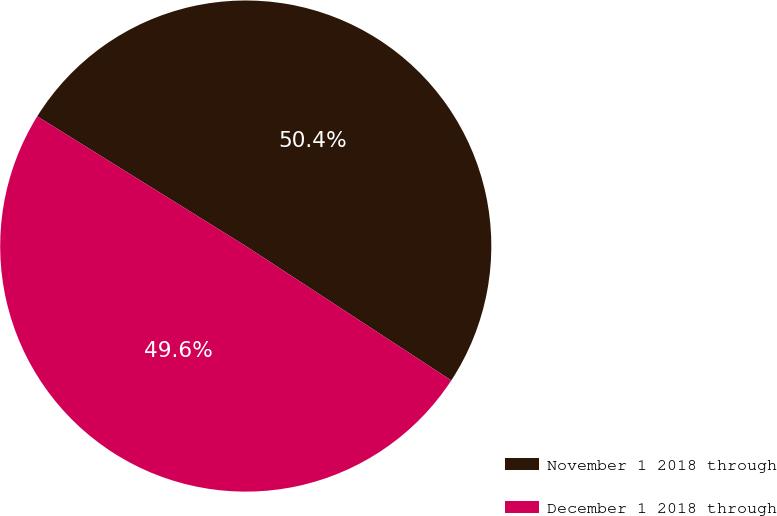Convert chart to OTSL. <chart><loc_0><loc_0><loc_500><loc_500><pie_chart><fcel>November 1 2018 through<fcel>December 1 2018 through<nl><fcel>50.36%<fcel>49.64%<nl></chart> 